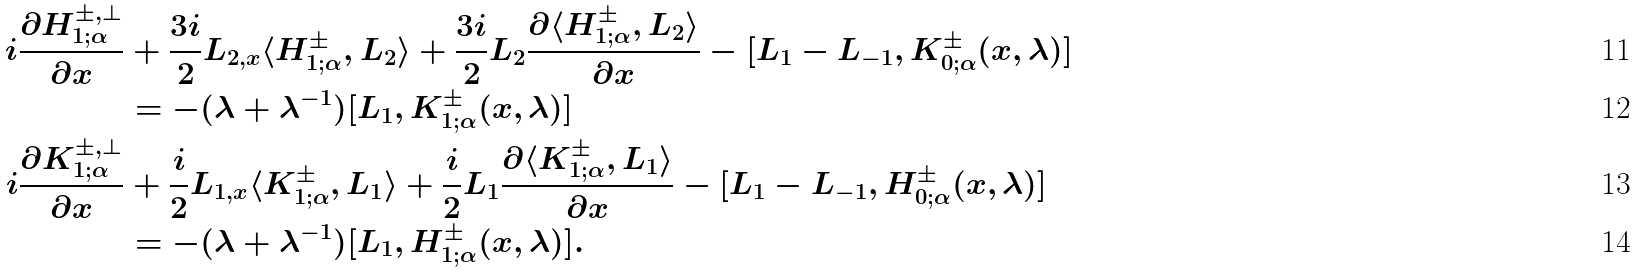<formula> <loc_0><loc_0><loc_500><loc_500>i \frac { \partial H _ { 1 ; \alpha } ^ { \pm , \perp } } { \partial x } & + \frac { 3 i } { 2 } L _ { 2 , x } \langle H _ { 1 ; \alpha } ^ { \pm } , L _ { 2 } \rangle + \frac { 3 i } { 2 } L _ { 2 } \frac { \partial \langle H _ { 1 ; \alpha } ^ { \pm } , L _ { 2 } \rangle } { \partial x } - [ L _ { 1 } - L _ { - 1 } , K _ { 0 ; \alpha } ^ { \pm } ( x , \lambda ) ] \\ & = - ( \lambda + \lambda ^ { - 1 } ) [ L _ { 1 } , K _ { 1 ; \alpha } ^ { \pm } ( x , \lambda ) ] \\ i \frac { \partial K _ { 1 ; \alpha } ^ { \pm , \perp } } { \partial x } & + \frac { i } { 2 } L _ { 1 , x } \langle K _ { 1 ; \alpha } ^ { \pm } , L _ { 1 } \rangle + \frac { i } { 2 } L _ { 1 } \frac { \partial \langle K _ { 1 ; \alpha } ^ { \pm } , L _ { 1 } \rangle } { \partial x } - [ L _ { 1 } - L _ { - 1 } , H _ { 0 ; \alpha } ^ { \pm } ( x , \lambda ) ] \\ & = - ( \lambda + \lambda ^ { - 1 } ) [ L _ { 1 } , H _ { 1 ; \alpha } ^ { \pm } ( x , \lambda ) ] .</formula> 